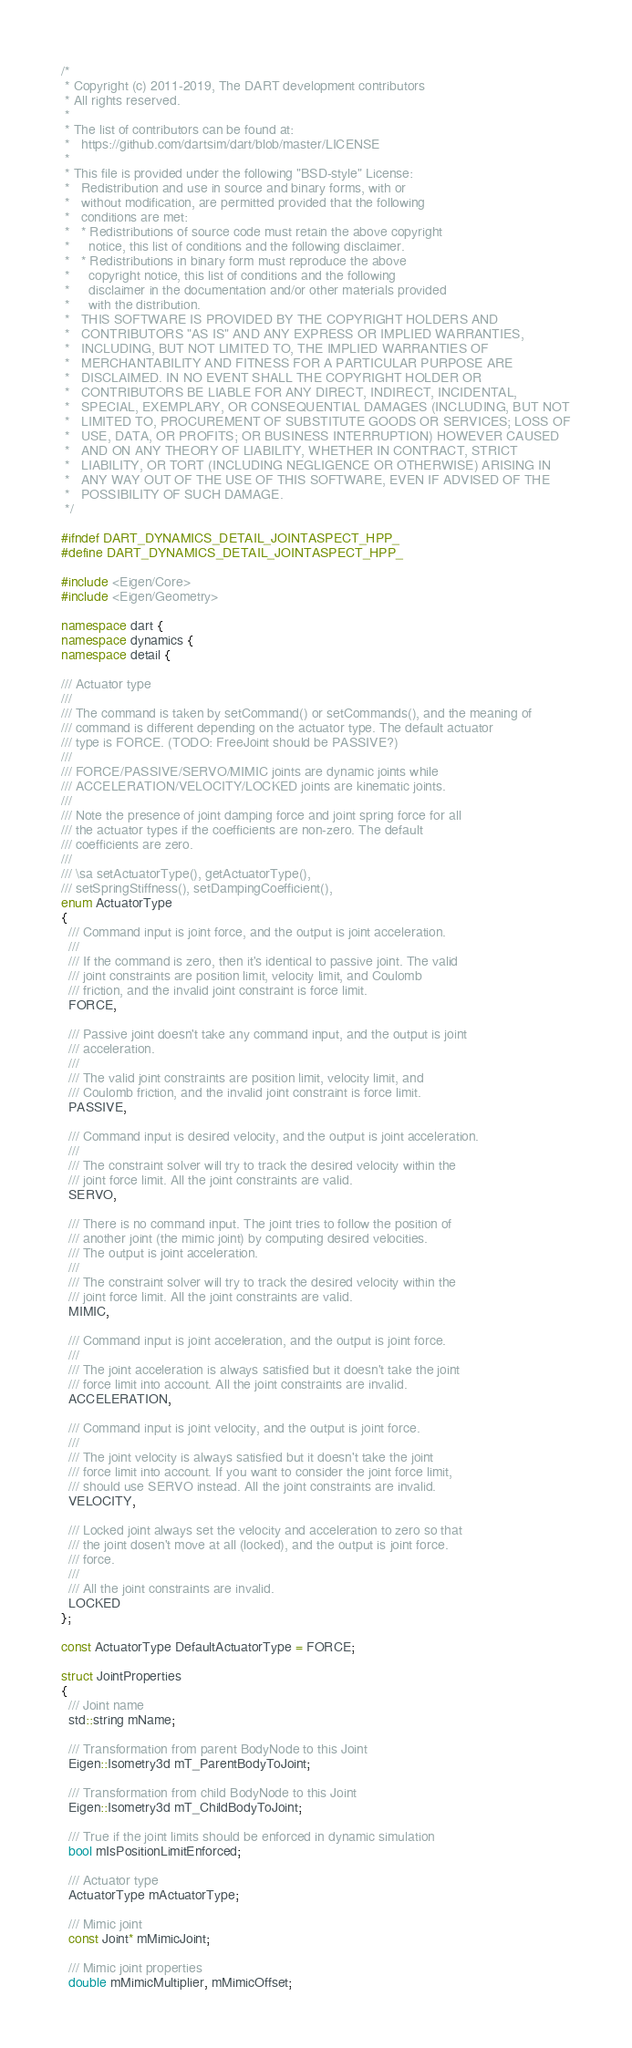Convert code to text. <code><loc_0><loc_0><loc_500><loc_500><_C++_>/*
 * Copyright (c) 2011-2019, The DART development contributors
 * All rights reserved.
 *
 * The list of contributors can be found at:
 *   https://github.com/dartsim/dart/blob/master/LICENSE
 *
 * This file is provided under the following "BSD-style" License:
 *   Redistribution and use in source and binary forms, with or
 *   without modification, are permitted provided that the following
 *   conditions are met:
 *   * Redistributions of source code must retain the above copyright
 *     notice, this list of conditions and the following disclaimer.
 *   * Redistributions in binary form must reproduce the above
 *     copyright notice, this list of conditions and the following
 *     disclaimer in the documentation and/or other materials provided
 *     with the distribution.
 *   THIS SOFTWARE IS PROVIDED BY THE COPYRIGHT HOLDERS AND
 *   CONTRIBUTORS "AS IS" AND ANY EXPRESS OR IMPLIED WARRANTIES,
 *   INCLUDING, BUT NOT LIMITED TO, THE IMPLIED WARRANTIES OF
 *   MERCHANTABILITY AND FITNESS FOR A PARTICULAR PURPOSE ARE
 *   DISCLAIMED. IN NO EVENT SHALL THE COPYRIGHT HOLDER OR
 *   CONTRIBUTORS BE LIABLE FOR ANY DIRECT, INDIRECT, INCIDENTAL,
 *   SPECIAL, EXEMPLARY, OR CONSEQUENTIAL DAMAGES (INCLUDING, BUT NOT
 *   LIMITED TO, PROCUREMENT OF SUBSTITUTE GOODS OR SERVICES; LOSS OF
 *   USE, DATA, OR PROFITS; OR BUSINESS INTERRUPTION) HOWEVER CAUSED
 *   AND ON ANY THEORY OF LIABILITY, WHETHER IN CONTRACT, STRICT
 *   LIABILITY, OR TORT (INCLUDING NEGLIGENCE OR OTHERWISE) ARISING IN
 *   ANY WAY OUT OF THE USE OF THIS SOFTWARE, EVEN IF ADVISED OF THE
 *   POSSIBILITY OF SUCH DAMAGE.
 */

#ifndef DART_DYNAMICS_DETAIL_JOINTASPECT_HPP_
#define DART_DYNAMICS_DETAIL_JOINTASPECT_HPP_

#include <Eigen/Core>
#include <Eigen/Geometry>

namespace dart {
namespace dynamics {
namespace detail {

/// Actuator type
///
/// The command is taken by setCommand() or setCommands(), and the meaning of
/// command is different depending on the actuator type. The default actuator
/// type is FORCE. (TODO: FreeJoint should be PASSIVE?)
///
/// FORCE/PASSIVE/SERVO/MIMIC joints are dynamic joints while
/// ACCELERATION/VELOCITY/LOCKED joints are kinematic joints.
///
/// Note the presence of joint damping force and joint spring force for all
/// the actuator types if the coefficients are non-zero. The default
/// coefficients are zero.
///
/// \sa setActuatorType(), getActuatorType(),
/// setSpringStiffness(), setDampingCoefficient(),
enum ActuatorType
{
  /// Command input is joint force, and the output is joint acceleration.
  ///
  /// If the command is zero, then it's identical to passive joint. The valid
  /// joint constraints are position limit, velocity limit, and Coulomb
  /// friction, and the invalid joint constraint is force limit.
  FORCE,

  /// Passive joint doesn't take any command input, and the output is joint
  /// acceleration.
  ///
  /// The valid joint constraints are position limit, velocity limit, and
  /// Coulomb friction, and the invalid joint constraint is force limit.
  PASSIVE,

  /// Command input is desired velocity, and the output is joint acceleration.
  ///
  /// The constraint solver will try to track the desired velocity within the
  /// joint force limit. All the joint constraints are valid.
  SERVO,

  /// There is no command input. The joint tries to follow the position of
  /// another joint (the mimic joint) by computing desired velocities.
  /// The output is joint acceleration.
  ///
  /// The constraint solver will try to track the desired velocity within the
  /// joint force limit. All the joint constraints are valid.
  MIMIC,

  /// Command input is joint acceleration, and the output is joint force.
  ///
  /// The joint acceleration is always satisfied but it doesn't take the joint
  /// force limit into account. All the joint constraints are invalid.
  ACCELERATION,

  /// Command input is joint velocity, and the output is joint force.
  ///
  /// The joint velocity is always satisfied but it doesn't take the joint
  /// force limit into account. If you want to consider the joint force limit,
  /// should use SERVO instead. All the joint constraints are invalid.
  VELOCITY,

  /// Locked joint always set the velocity and acceleration to zero so that
  /// the joint dosen't move at all (locked), and the output is joint force.
  /// force.
  ///
  /// All the joint constraints are invalid.
  LOCKED
};

const ActuatorType DefaultActuatorType = FORCE;

struct JointProperties
{
  /// Joint name
  std::string mName;

  /// Transformation from parent BodyNode to this Joint
  Eigen::Isometry3d mT_ParentBodyToJoint;

  /// Transformation from child BodyNode to this Joint
  Eigen::Isometry3d mT_ChildBodyToJoint;

  /// True if the joint limits should be enforced in dynamic simulation
  bool mIsPositionLimitEnforced;

  /// Actuator type
  ActuatorType mActuatorType;

  /// Mimic joint
  const Joint* mMimicJoint;

  /// Mimic joint properties
  double mMimicMultiplier, mMimicOffset;
</code> 